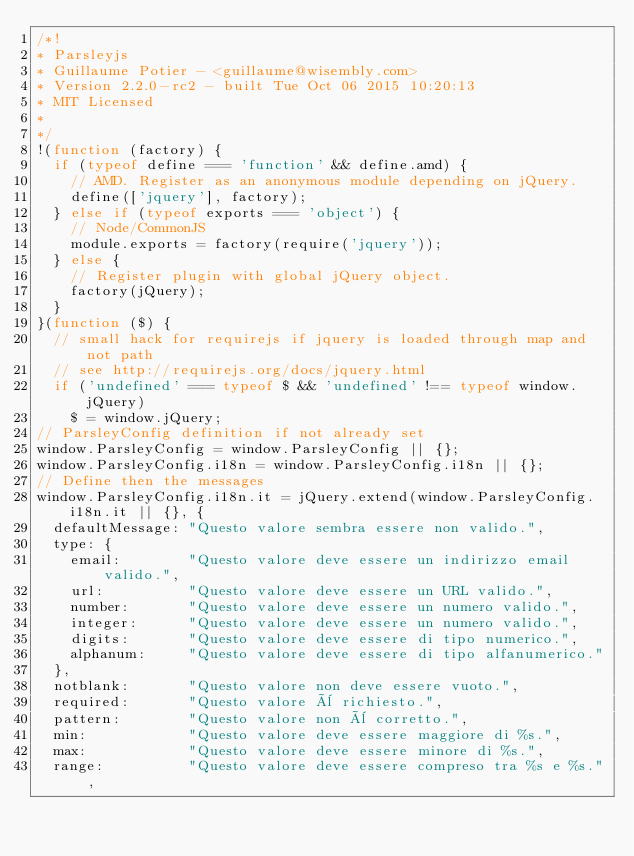<code> <loc_0><loc_0><loc_500><loc_500><_JavaScript_>/*!
* Parsleyjs
* Guillaume Potier - <guillaume@wisembly.com>
* Version 2.2.0-rc2 - built Tue Oct 06 2015 10:20:13
* MIT Licensed
*
*/
!(function (factory) {
  if (typeof define === 'function' && define.amd) {
    // AMD. Register as an anonymous module depending on jQuery.
    define(['jquery'], factory);
  } else if (typeof exports === 'object') {
    // Node/CommonJS
    module.exports = factory(require('jquery'));
  } else {
    // Register plugin with global jQuery object.
    factory(jQuery);
  }
}(function ($) {
  // small hack for requirejs if jquery is loaded through map and not path
  // see http://requirejs.org/docs/jquery.html
  if ('undefined' === typeof $ && 'undefined' !== typeof window.jQuery)
    $ = window.jQuery;
// ParsleyConfig definition if not already set
window.ParsleyConfig = window.ParsleyConfig || {};
window.ParsleyConfig.i18n = window.ParsleyConfig.i18n || {};
// Define then the messages
window.ParsleyConfig.i18n.it = jQuery.extend(window.ParsleyConfig.i18n.it || {}, {
  defaultMessage: "Questo valore sembra essere non valido.",
  type: {
    email:        "Questo valore deve essere un indirizzo email valido.",
    url:          "Questo valore deve essere un URL valido.",
    number:       "Questo valore deve essere un numero valido.",
    integer:      "Questo valore deve essere un numero valido.",
    digits:       "Questo valore deve essere di tipo numerico.",
    alphanum:     "Questo valore deve essere di tipo alfanumerico."
  },
  notblank:       "Questo valore non deve essere vuoto.",
  required:       "Questo valore è richiesto.",
  pattern:        "Questo valore non è corretto.",
  min:            "Questo valore deve essere maggiore di %s.",
  max:            "Questo valore deve essere minore di %s.",
  range:          "Questo valore deve essere compreso tra %s e %s.",</code> 